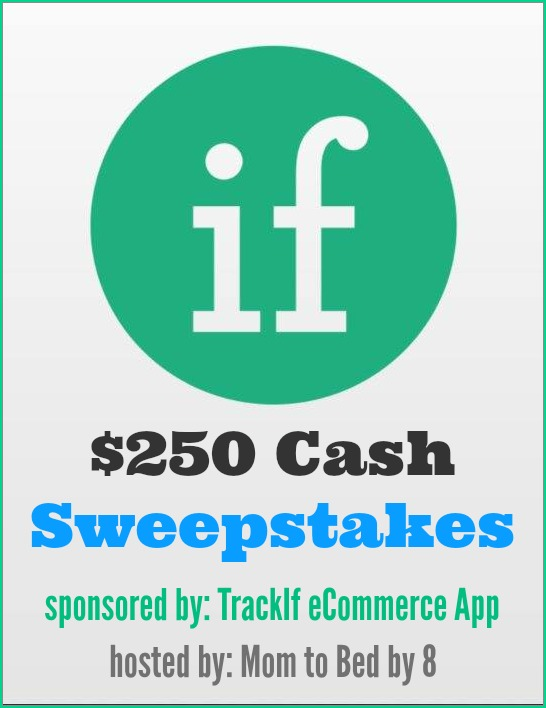If TrackIf eCommerce App had magical properties, what could they be, and how would they enhance the sweepstakes? Imagine if TrackIf eCommerce App had magical properties! With a touch of enchantment, the app could instantly transform into a personal eCommerce genie. This magical app would not only track price drops but also create personalized coupons and discounts out of thin air, ensuring that customers always get the best deals. Moreover, it could foresee future sales and predict the perfect time to buy desired products. During the sweepstakes, this enchanted app could offer daily mini-prizes that appear as surprise notifications, keeping participants excited and engaged. The grand prize, instead of just $250 in cash, could include a golden ticket unlocking a year of magical bargains and exclusive access to the best sales and deals around the world, making every user's shopping dreams come true! 